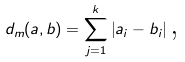Convert formula to latex. <formula><loc_0><loc_0><loc_500><loc_500>d _ { m } ( a , b ) = \sum _ { j = 1 } ^ { k } \left | a _ { i } - b _ { i } \right | \text {,}</formula> 